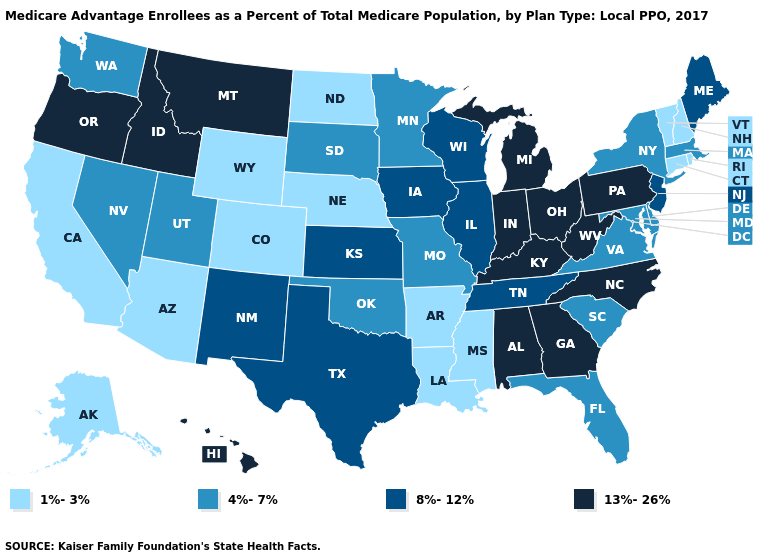Name the states that have a value in the range 1%-3%?
Write a very short answer. Alaska, Arkansas, Arizona, California, Colorado, Connecticut, Louisiana, Mississippi, North Dakota, Nebraska, New Hampshire, Rhode Island, Vermont, Wyoming. Is the legend a continuous bar?
Keep it brief. No. What is the value of Rhode Island?
Keep it brief. 1%-3%. Among the states that border Nevada , does California have the lowest value?
Write a very short answer. Yes. What is the lowest value in states that border Vermont?
Give a very brief answer. 1%-3%. What is the value of Florida?
Be succinct. 4%-7%. Among the states that border Rhode Island , which have the lowest value?
Short answer required. Connecticut. Does the first symbol in the legend represent the smallest category?
Concise answer only. Yes. What is the value of New Jersey?
Answer briefly. 8%-12%. How many symbols are there in the legend?
Be succinct. 4. Among the states that border North Carolina , which have the highest value?
Write a very short answer. Georgia. What is the value of Ohio?
Short answer required. 13%-26%. Name the states that have a value in the range 8%-12%?
Concise answer only. Iowa, Illinois, Kansas, Maine, New Jersey, New Mexico, Tennessee, Texas, Wisconsin. What is the highest value in states that border Arizona?
Short answer required. 8%-12%. Does Wisconsin have the highest value in the MidWest?
Keep it brief. No. 